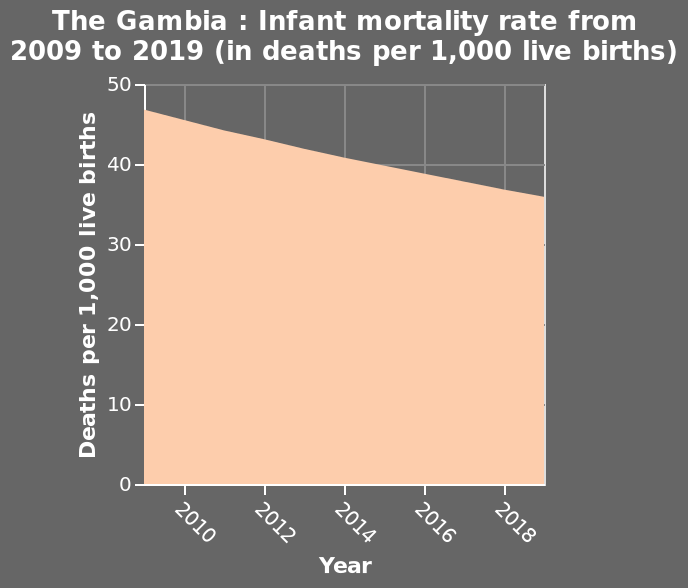<image>
What is the range of the x-axis for the infant mortality rate diagram in The Gambia? The range of the x-axis is from 2010 to 2018 in years. 